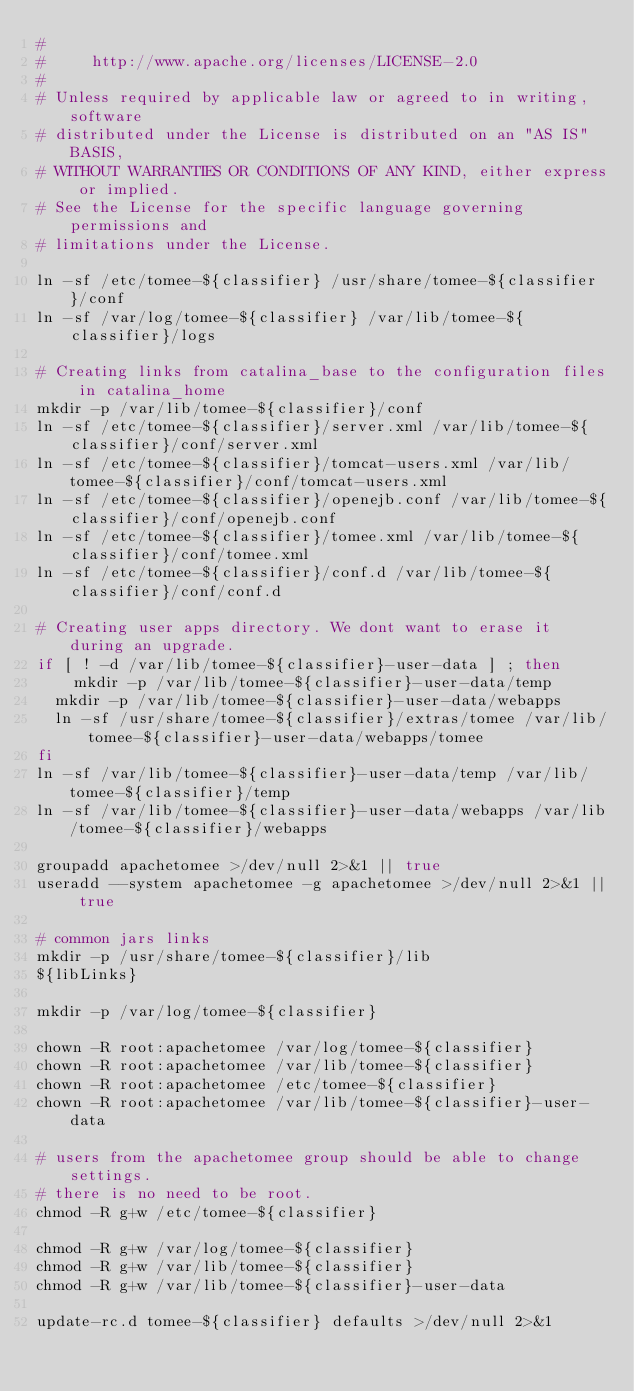Convert code to text. <code><loc_0><loc_0><loc_500><loc_500><_Bash_>#
#     http://www.apache.org/licenses/LICENSE-2.0
#
# Unless required by applicable law or agreed to in writing, software
# distributed under the License is distributed on an "AS IS" BASIS,
# WITHOUT WARRANTIES OR CONDITIONS OF ANY KIND, either express or implied.
# See the License for the specific language governing permissions and
# limitations under the License.

ln -sf /etc/tomee-${classifier} /usr/share/tomee-${classifier}/conf
ln -sf /var/log/tomee-${classifier} /var/lib/tomee-${classifier}/logs

# Creating links from catalina_base to the configuration files in catalina_home
mkdir -p /var/lib/tomee-${classifier}/conf
ln -sf /etc/tomee-${classifier}/server.xml /var/lib/tomee-${classifier}/conf/server.xml
ln -sf /etc/tomee-${classifier}/tomcat-users.xml /var/lib/tomee-${classifier}/conf/tomcat-users.xml
ln -sf /etc/tomee-${classifier}/openejb.conf /var/lib/tomee-${classifier}/conf/openejb.conf
ln -sf /etc/tomee-${classifier}/tomee.xml /var/lib/tomee-${classifier}/conf/tomee.xml
ln -sf /etc/tomee-${classifier}/conf.d /var/lib/tomee-${classifier}/conf/conf.d

# Creating user apps directory. We dont want to erase it during an upgrade.
if [ ! -d /var/lib/tomee-${classifier}-user-data ] ; then
    mkdir -p /var/lib/tomee-${classifier}-user-data/temp
	mkdir -p /var/lib/tomee-${classifier}-user-data/webapps
	ln -sf /usr/share/tomee-${classifier}/extras/tomee /var/lib/tomee-${classifier}-user-data/webapps/tomee
fi
ln -sf /var/lib/tomee-${classifier}-user-data/temp /var/lib/tomee-${classifier}/temp
ln -sf /var/lib/tomee-${classifier}-user-data/webapps /var/lib/tomee-${classifier}/webapps

groupadd apachetomee >/dev/null 2>&1 || true
useradd --system apachetomee -g apachetomee >/dev/null 2>&1 || true

# common jars links
mkdir -p /usr/share/tomee-${classifier}/lib
${libLinks}

mkdir -p /var/log/tomee-${classifier}

chown -R root:apachetomee /var/log/tomee-${classifier}
chown -R root:apachetomee /var/lib/tomee-${classifier}
chown -R root:apachetomee /etc/tomee-${classifier}
chown -R root:apachetomee /var/lib/tomee-${classifier}-user-data

# users from the apachetomee group should be able to change settings.
# there is no need to be root.
chmod -R g+w /etc/tomee-${classifier}

chmod -R g+w /var/log/tomee-${classifier}
chmod -R g+w /var/lib/tomee-${classifier}
chmod -R g+w /var/lib/tomee-${classifier}-user-data

update-rc.d tomee-${classifier} defaults >/dev/null 2>&1
</code> 